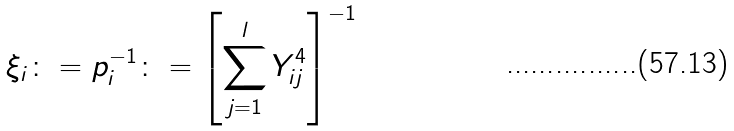Convert formula to latex. <formula><loc_0><loc_0><loc_500><loc_500>\xi _ { i } \colon = p _ { i } ^ { - 1 } \colon = \left [ \sum _ { j = 1 } ^ { l } Y _ { i j } ^ { 4 } \right ] ^ { - 1 }</formula> 